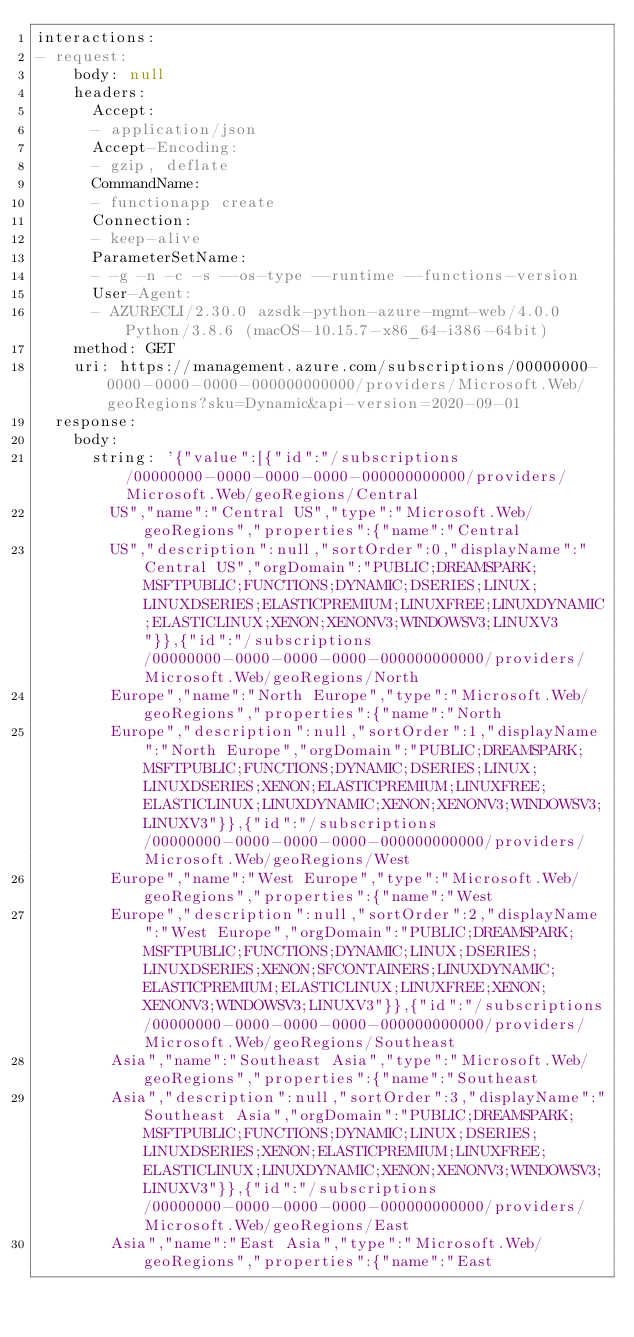Convert code to text. <code><loc_0><loc_0><loc_500><loc_500><_YAML_>interactions:
- request:
    body: null
    headers:
      Accept:
      - application/json
      Accept-Encoding:
      - gzip, deflate
      CommandName:
      - functionapp create
      Connection:
      - keep-alive
      ParameterSetName:
      - -g -n -c -s --os-type --runtime --functions-version
      User-Agent:
      - AZURECLI/2.30.0 azsdk-python-azure-mgmt-web/4.0.0 Python/3.8.6 (macOS-10.15.7-x86_64-i386-64bit)
    method: GET
    uri: https://management.azure.com/subscriptions/00000000-0000-0000-0000-000000000000/providers/Microsoft.Web/geoRegions?sku=Dynamic&api-version=2020-09-01
  response:
    body:
      string: '{"value":[{"id":"/subscriptions/00000000-0000-0000-0000-000000000000/providers/Microsoft.Web/geoRegions/Central
        US","name":"Central US","type":"Microsoft.Web/geoRegions","properties":{"name":"Central
        US","description":null,"sortOrder":0,"displayName":"Central US","orgDomain":"PUBLIC;DREAMSPARK;MSFTPUBLIC;FUNCTIONS;DYNAMIC;DSERIES;LINUX;LINUXDSERIES;ELASTICPREMIUM;LINUXFREE;LINUXDYNAMIC;ELASTICLINUX;XENON;XENONV3;WINDOWSV3;LINUXV3"}},{"id":"/subscriptions/00000000-0000-0000-0000-000000000000/providers/Microsoft.Web/geoRegions/North
        Europe","name":"North Europe","type":"Microsoft.Web/geoRegions","properties":{"name":"North
        Europe","description":null,"sortOrder":1,"displayName":"North Europe","orgDomain":"PUBLIC;DREAMSPARK;MSFTPUBLIC;FUNCTIONS;DYNAMIC;DSERIES;LINUX;LINUXDSERIES;XENON;ELASTICPREMIUM;LINUXFREE;ELASTICLINUX;LINUXDYNAMIC;XENON;XENONV3;WINDOWSV3;LINUXV3"}},{"id":"/subscriptions/00000000-0000-0000-0000-000000000000/providers/Microsoft.Web/geoRegions/West
        Europe","name":"West Europe","type":"Microsoft.Web/geoRegions","properties":{"name":"West
        Europe","description":null,"sortOrder":2,"displayName":"West Europe","orgDomain":"PUBLIC;DREAMSPARK;MSFTPUBLIC;FUNCTIONS;DYNAMIC;LINUX;DSERIES;LINUXDSERIES;XENON;SFCONTAINERS;LINUXDYNAMIC;ELASTICPREMIUM;ELASTICLINUX;LINUXFREE;XENON;XENONV3;WINDOWSV3;LINUXV3"}},{"id":"/subscriptions/00000000-0000-0000-0000-000000000000/providers/Microsoft.Web/geoRegions/Southeast
        Asia","name":"Southeast Asia","type":"Microsoft.Web/geoRegions","properties":{"name":"Southeast
        Asia","description":null,"sortOrder":3,"displayName":"Southeast Asia","orgDomain":"PUBLIC;DREAMSPARK;MSFTPUBLIC;FUNCTIONS;DYNAMIC;LINUX;DSERIES;LINUXDSERIES;XENON;ELASTICPREMIUM;LINUXFREE;ELASTICLINUX;LINUXDYNAMIC;XENON;XENONV3;WINDOWSV3;LINUXV3"}},{"id":"/subscriptions/00000000-0000-0000-0000-000000000000/providers/Microsoft.Web/geoRegions/East
        Asia","name":"East Asia","type":"Microsoft.Web/geoRegions","properties":{"name":"East</code> 